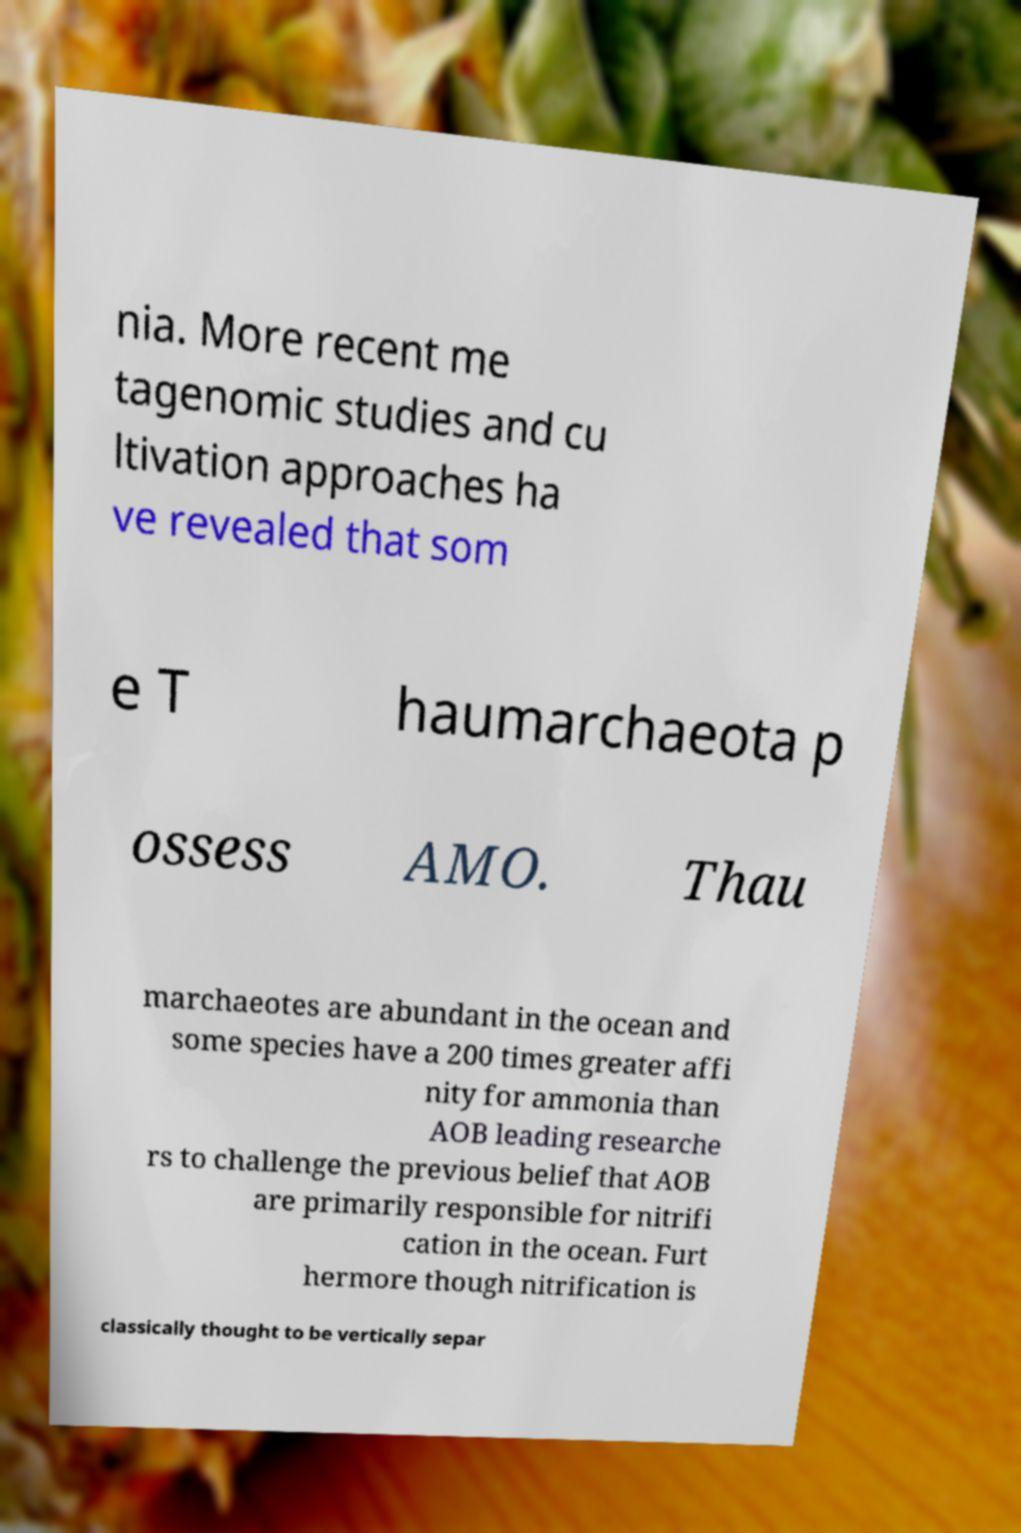I need the written content from this picture converted into text. Can you do that? nia. More recent me tagenomic studies and cu ltivation approaches ha ve revealed that som e T haumarchaeota p ossess AMO. Thau marchaeotes are abundant in the ocean and some species have a 200 times greater affi nity for ammonia than AOB leading researche rs to challenge the previous belief that AOB are primarily responsible for nitrifi cation in the ocean. Furt hermore though nitrification is classically thought to be vertically separ 